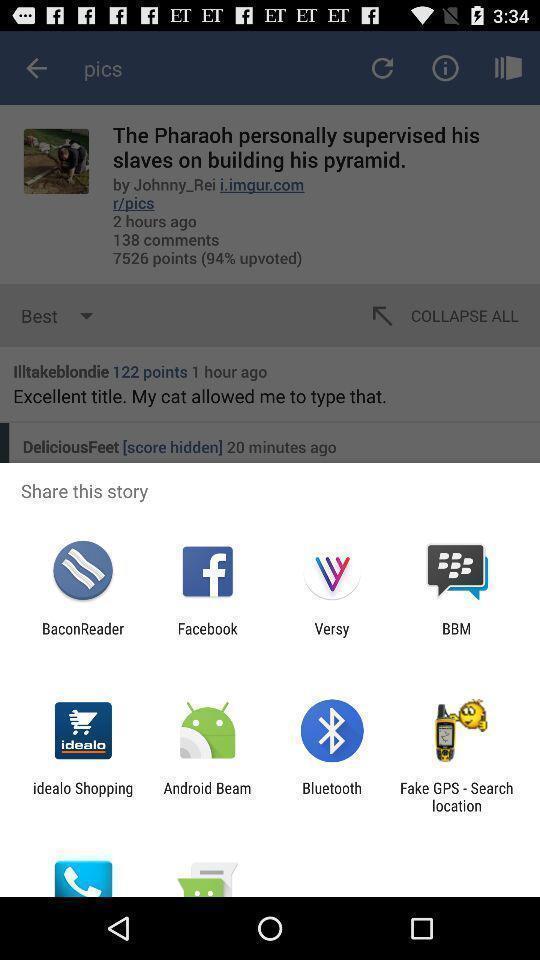Provide a description of this screenshot. Push up showing for social apps. 